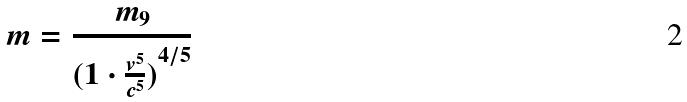<formula> <loc_0><loc_0><loc_500><loc_500>m = \frac { m _ { 9 } } { ( { 1 \cdot \frac { v ^ { 5 } } { c ^ { 5 } } ) } ^ { 4 / 5 } }</formula> 